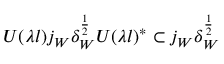<formula> <loc_0><loc_0><loc_500><loc_500>U ( \lambda l ) j _ { W } \delta _ { W } ^ { \frac { 1 } { 2 } } U ( \lambda l ) ^ { * } \subset j _ { W } \delta _ { W } ^ { \frac { 1 } { 2 } }</formula> 